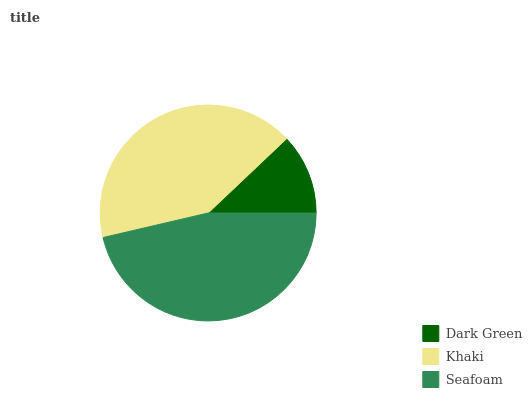Is Dark Green the minimum?
Answer yes or no. Yes. Is Seafoam the maximum?
Answer yes or no. Yes. Is Khaki the minimum?
Answer yes or no. No. Is Khaki the maximum?
Answer yes or no. No. Is Khaki greater than Dark Green?
Answer yes or no. Yes. Is Dark Green less than Khaki?
Answer yes or no. Yes. Is Dark Green greater than Khaki?
Answer yes or no. No. Is Khaki less than Dark Green?
Answer yes or no. No. Is Khaki the high median?
Answer yes or no. Yes. Is Khaki the low median?
Answer yes or no. Yes. Is Dark Green the high median?
Answer yes or no. No. Is Dark Green the low median?
Answer yes or no. No. 